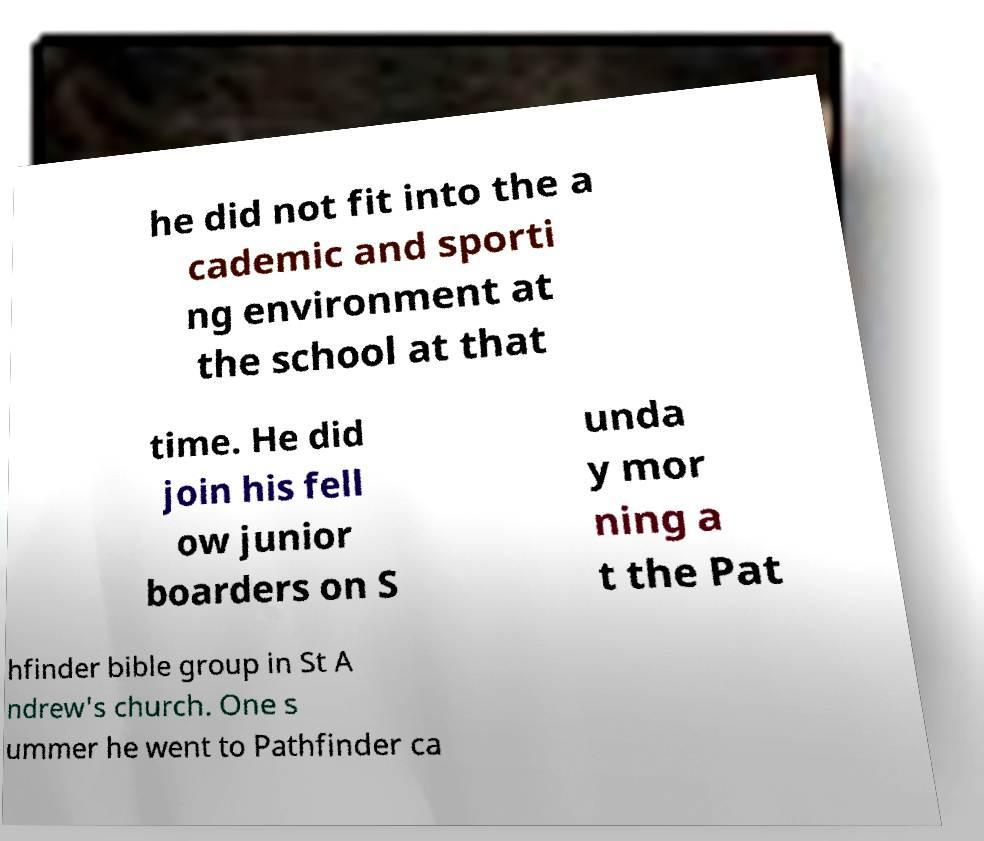For documentation purposes, I need the text within this image transcribed. Could you provide that? he did not fit into the a cademic and sporti ng environment at the school at that time. He did join his fell ow junior boarders on S unda y mor ning a t the Pat hfinder bible group in St A ndrew's church. One s ummer he went to Pathfinder ca 